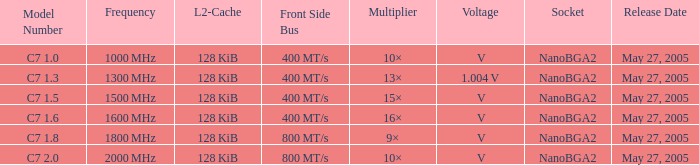What is the launch date for model number c7 May 27, 2005. 